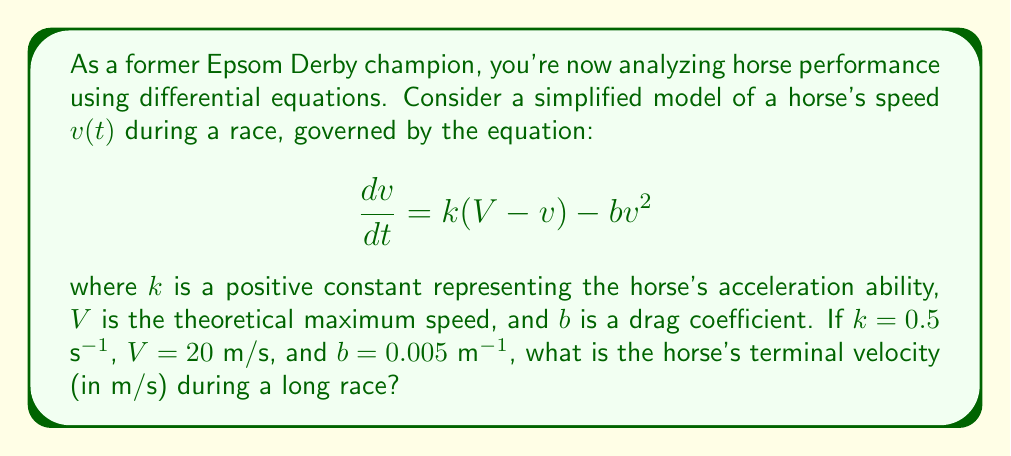Give your solution to this math problem. To find the terminal velocity, we need to determine the speed at which the horse's acceleration becomes zero. This occurs when the right-hand side of the differential equation equals zero:

$$k(V - v) - bv^2 = 0$$

Substituting the given values:

$$0.5(20 - v) - 0.005v^2 = 0$$

Simplifying:

$$10 - 0.5v - 0.005v^2 = 0$$

Rearranging to standard quadratic form:

$$0.005v^2 + 0.5v - 10 = 0$$

Now we can solve this using the quadratic formula:

$$v = \frac{-b \pm \sqrt{b^2 - 4ac}}{2a}$$

Where $a = 0.005$, $b = 0.5$, and $c = -10$

$$v = \frac{-0.5 \pm \sqrt{0.5^2 - 4(0.005)(-10)}}{2(0.005)}$$

$$v = \frac{-0.5 \pm \sqrt{0.25 + 0.2}}{0.01}$$

$$v = \frac{-0.5 \pm \sqrt{0.45}}{0.01}$$

$$v = \frac{-0.5 \pm 0.6708}{0.01}$$

This gives us two solutions:

$$v_1 = \frac{-0.5 + 0.6708}{0.01} = 17.08 \text{ m/s}$$

$$v_2 = \frac{-0.5 - 0.6708}{0.01} = -117.08 \text{ m/s}$$

Since negative velocity doesn't make physical sense in this context, we discard the second solution.
Answer: The horse's terminal velocity is approximately 17.08 m/s. 